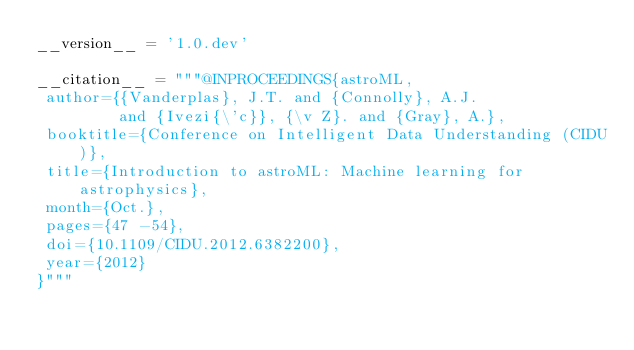<code> <loc_0><loc_0><loc_500><loc_500><_Python_>__version__ = '1.0.dev'

__citation__ = """@INPROCEEDINGS{astroML,
 author={{Vanderplas}, J.T. and {Connolly}, A.J.
         and {Ivezi{\'c}}, {\v Z}. and {Gray}, A.},
 booktitle={Conference on Intelligent Data Understanding (CIDU)},
 title={Introduction to astroML: Machine learning for astrophysics},
 month={Oct.},
 pages={47 -54},
 doi={10.1109/CIDU.2012.6382200},
 year={2012}
}"""
</code> 